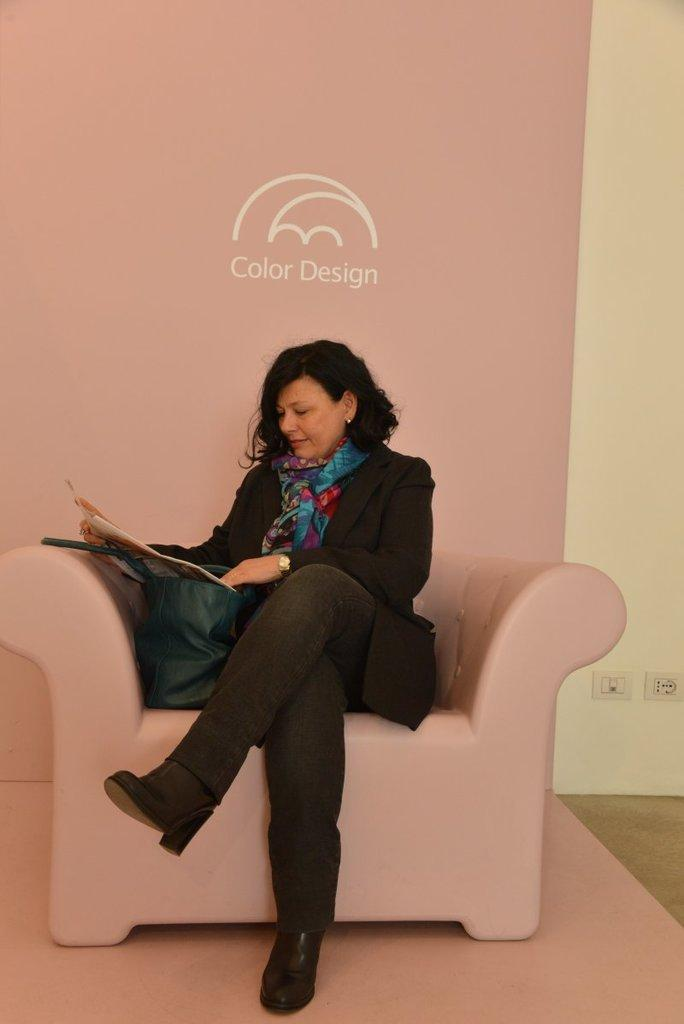Who is the main subject in the picture? There is a woman in the picture. What is the woman doing in the image? The woman is sitting on a couch and reading a book. How does the woman appear to feel in the image? The woman is smiling in the image. What is the purpose of the engine in the image? There is no engine present in the image; it features a woman sitting on a couch and reading a book. 